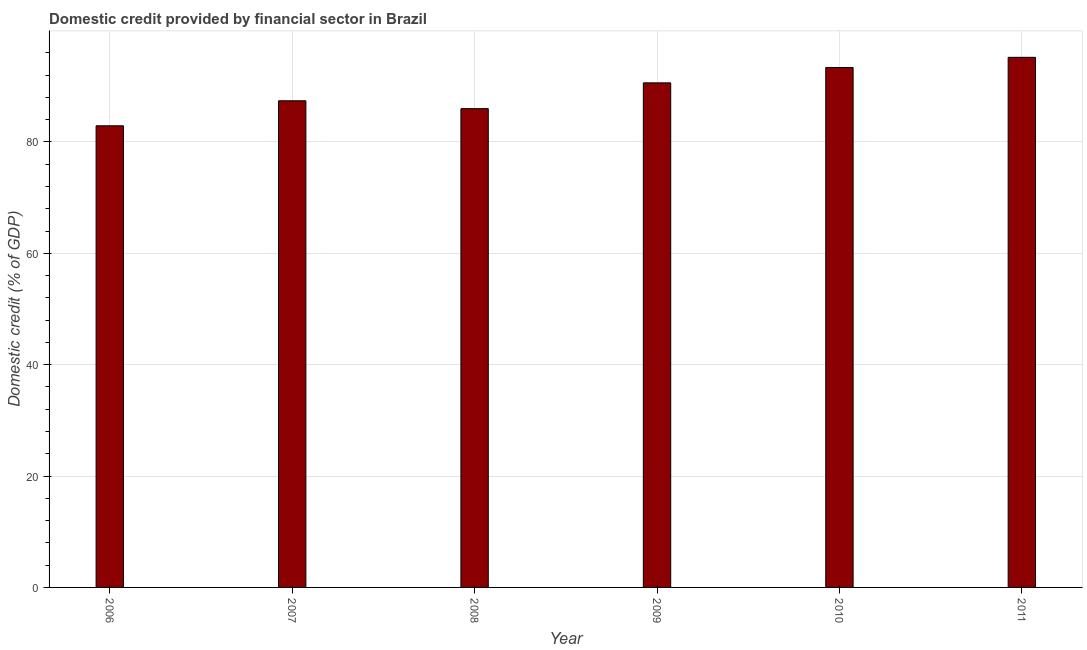Does the graph contain any zero values?
Provide a succinct answer. No. Does the graph contain grids?
Offer a very short reply. Yes. What is the title of the graph?
Ensure brevity in your answer.  Domestic credit provided by financial sector in Brazil. What is the label or title of the X-axis?
Your response must be concise. Year. What is the label or title of the Y-axis?
Ensure brevity in your answer.  Domestic credit (% of GDP). What is the domestic credit provided by financial sector in 2009?
Provide a short and direct response. 90.61. Across all years, what is the maximum domestic credit provided by financial sector?
Give a very brief answer. 95.19. Across all years, what is the minimum domestic credit provided by financial sector?
Keep it short and to the point. 82.9. What is the sum of the domestic credit provided by financial sector?
Give a very brief answer. 535.42. What is the difference between the domestic credit provided by financial sector in 2008 and 2010?
Your answer should be very brief. -7.39. What is the average domestic credit provided by financial sector per year?
Your answer should be very brief. 89.24. What is the median domestic credit provided by financial sector?
Your answer should be compact. 89. In how many years, is the domestic credit provided by financial sector greater than 32 %?
Your response must be concise. 6. Do a majority of the years between 2010 and 2007 (inclusive) have domestic credit provided by financial sector greater than 48 %?
Give a very brief answer. Yes. What is the ratio of the domestic credit provided by financial sector in 2007 to that in 2010?
Provide a succinct answer. 0.94. Is the domestic credit provided by financial sector in 2009 less than that in 2011?
Your answer should be compact. Yes. Is the difference between the domestic credit provided by financial sector in 2009 and 2010 greater than the difference between any two years?
Make the answer very short. No. What is the difference between the highest and the second highest domestic credit provided by financial sector?
Your answer should be very brief. 1.83. Is the sum of the domestic credit provided by financial sector in 2007 and 2009 greater than the maximum domestic credit provided by financial sector across all years?
Give a very brief answer. Yes. What is the difference between the highest and the lowest domestic credit provided by financial sector?
Your answer should be very brief. 12.29. In how many years, is the domestic credit provided by financial sector greater than the average domestic credit provided by financial sector taken over all years?
Give a very brief answer. 3. Are all the bars in the graph horizontal?
Offer a terse response. No. What is the difference between two consecutive major ticks on the Y-axis?
Your answer should be very brief. 20. Are the values on the major ticks of Y-axis written in scientific E-notation?
Ensure brevity in your answer.  No. What is the Domestic credit (% of GDP) of 2006?
Your answer should be very brief. 82.9. What is the Domestic credit (% of GDP) in 2007?
Ensure brevity in your answer.  87.39. What is the Domestic credit (% of GDP) of 2008?
Keep it short and to the point. 85.97. What is the Domestic credit (% of GDP) in 2009?
Your response must be concise. 90.61. What is the Domestic credit (% of GDP) in 2010?
Give a very brief answer. 93.36. What is the Domestic credit (% of GDP) of 2011?
Give a very brief answer. 95.19. What is the difference between the Domestic credit (% of GDP) in 2006 and 2007?
Make the answer very short. -4.49. What is the difference between the Domestic credit (% of GDP) in 2006 and 2008?
Offer a terse response. -3.07. What is the difference between the Domestic credit (% of GDP) in 2006 and 2009?
Your answer should be compact. -7.71. What is the difference between the Domestic credit (% of GDP) in 2006 and 2010?
Provide a succinct answer. -10.47. What is the difference between the Domestic credit (% of GDP) in 2006 and 2011?
Your answer should be very brief. -12.29. What is the difference between the Domestic credit (% of GDP) in 2007 and 2008?
Ensure brevity in your answer.  1.42. What is the difference between the Domestic credit (% of GDP) in 2007 and 2009?
Your answer should be very brief. -3.22. What is the difference between the Domestic credit (% of GDP) in 2007 and 2010?
Keep it short and to the point. -5.98. What is the difference between the Domestic credit (% of GDP) in 2007 and 2011?
Your response must be concise. -7.8. What is the difference between the Domestic credit (% of GDP) in 2008 and 2009?
Make the answer very short. -4.64. What is the difference between the Domestic credit (% of GDP) in 2008 and 2010?
Your answer should be very brief. -7.39. What is the difference between the Domestic credit (% of GDP) in 2008 and 2011?
Provide a short and direct response. -9.22. What is the difference between the Domestic credit (% of GDP) in 2009 and 2010?
Ensure brevity in your answer.  -2.76. What is the difference between the Domestic credit (% of GDP) in 2009 and 2011?
Give a very brief answer. -4.58. What is the difference between the Domestic credit (% of GDP) in 2010 and 2011?
Your response must be concise. -1.83. What is the ratio of the Domestic credit (% of GDP) in 2006 to that in 2007?
Your answer should be compact. 0.95. What is the ratio of the Domestic credit (% of GDP) in 2006 to that in 2008?
Give a very brief answer. 0.96. What is the ratio of the Domestic credit (% of GDP) in 2006 to that in 2009?
Keep it short and to the point. 0.92. What is the ratio of the Domestic credit (% of GDP) in 2006 to that in 2010?
Make the answer very short. 0.89. What is the ratio of the Domestic credit (% of GDP) in 2006 to that in 2011?
Your answer should be compact. 0.87. What is the ratio of the Domestic credit (% of GDP) in 2007 to that in 2008?
Your answer should be compact. 1.02. What is the ratio of the Domestic credit (% of GDP) in 2007 to that in 2010?
Make the answer very short. 0.94. What is the ratio of the Domestic credit (% of GDP) in 2007 to that in 2011?
Make the answer very short. 0.92. What is the ratio of the Domestic credit (% of GDP) in 2008 to that in 2009?
Ensure brevity in your answer.  0.95. What is the ratio of the Domestic credit (% of GDP) in 2008 to that in 2010?
Your answer should be compact. 0.92. What is the ratio of the Domestic credit (% of GDP) in 2008 to that in 2011?
Give a very brief answer. 0.9. What is the ratio of the Domestic credit (% of GDP) in 2009 to that in 2010?
Provide a short and direct response. 0.97. What is the ratio of the Domestic credit (% of GDP) in 2010 to that in 2011?
Your answer should be very brief. 0.98. 